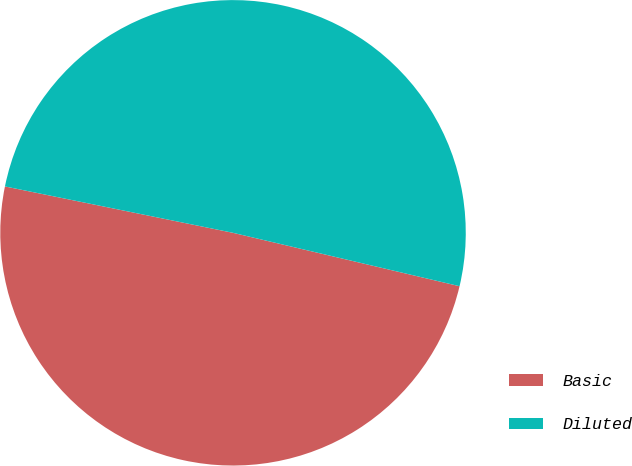Convert chart to OTSL. <chart><loc_0><loc_0><loc_500><loc_500><pie_chart><fcel>Basic<fcel>Diluted<nl><fcel>49.51%<fcel>50.49%<nl></chart> 